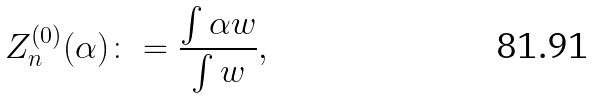Convert formula to latex. <formula><loc_0><loc_0><loc_500><loc_500>Z ^ { ( 0 ) } _ { n } ( \alpha ) \colon = \frac { \int \alpha w } { \int w } ,</formula> 